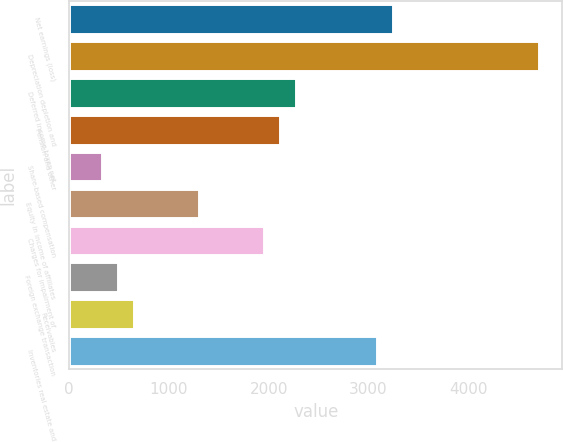<chart> <loc_0><loc_0><loc_500><loc_500><bar_chart><fcel>Net earnings (loss)<fcel>Depreciation depletion and<fcel>Deferred income taxes net<fcel>Pension and other<fcel>Share-based compensation<fcel>Equity in income of affiliates<fcel>Charges for impairment of<fcel>Foreign exchange transaction<fcel>Receivables<fcel>Inventories real estate and<nl><fcel>3247<fcel>4707.7<fcel>2273.2<fcel>2110.9<fcel>325.6<fcel>1299.4<fcel>1948.6<fcel>487.9<fcel>650.2<fcel>3084.7<nl></chart> 